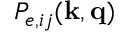Convert formula to latex. <formula><loc_0><loc_0><loc_500><loc_500>P _ { e , i j } ( k , q )</formula> 